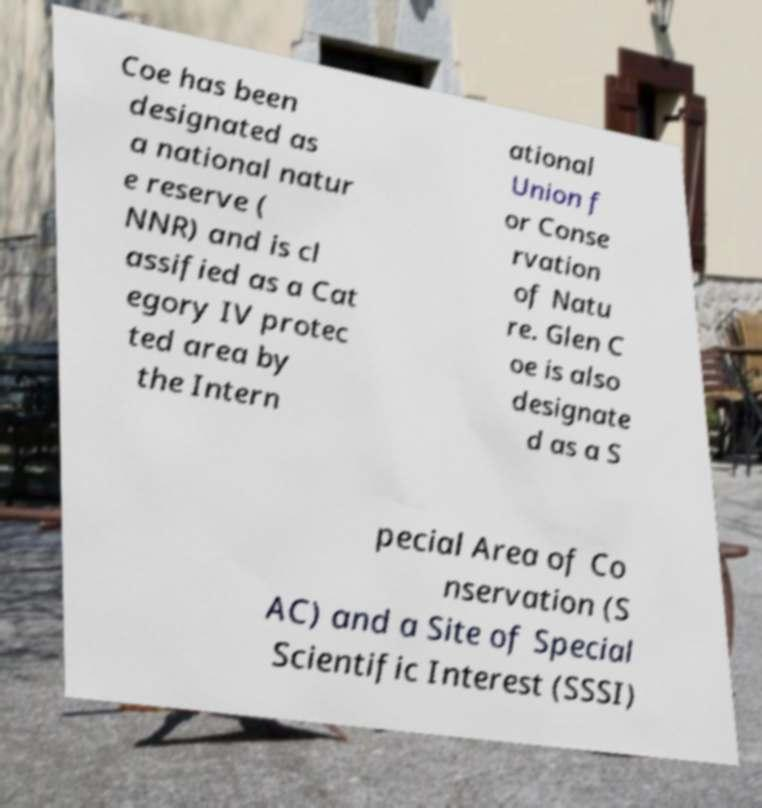What messages or text are displayed in this image? I need them in a readable, typed format. Coe has been designated as a national natur e reserve ( NNR) and is cl assified as a Cat egory IV protec ted area by the Intern ational Union f or Conse rvation of Natu re. Glen C oe is also designate d as a S pecial Area of Co nservation (S AC) and a Site of Special Scientific Interest (SSSI) 